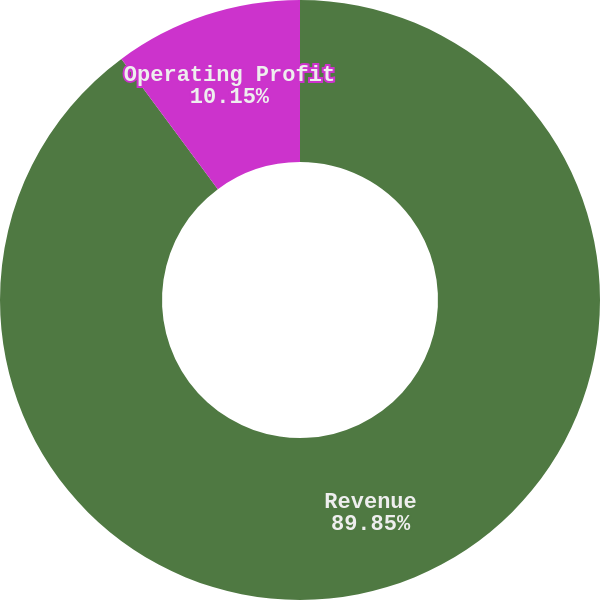Convert chart to OTSL. <chart><loc_0><loc_0><loc_500><loc_500><pie_chart><fcel>Revenue<fcel>Operating Profit<nl><fcel>89.85%<fcel>10.15%<nl></chart> 